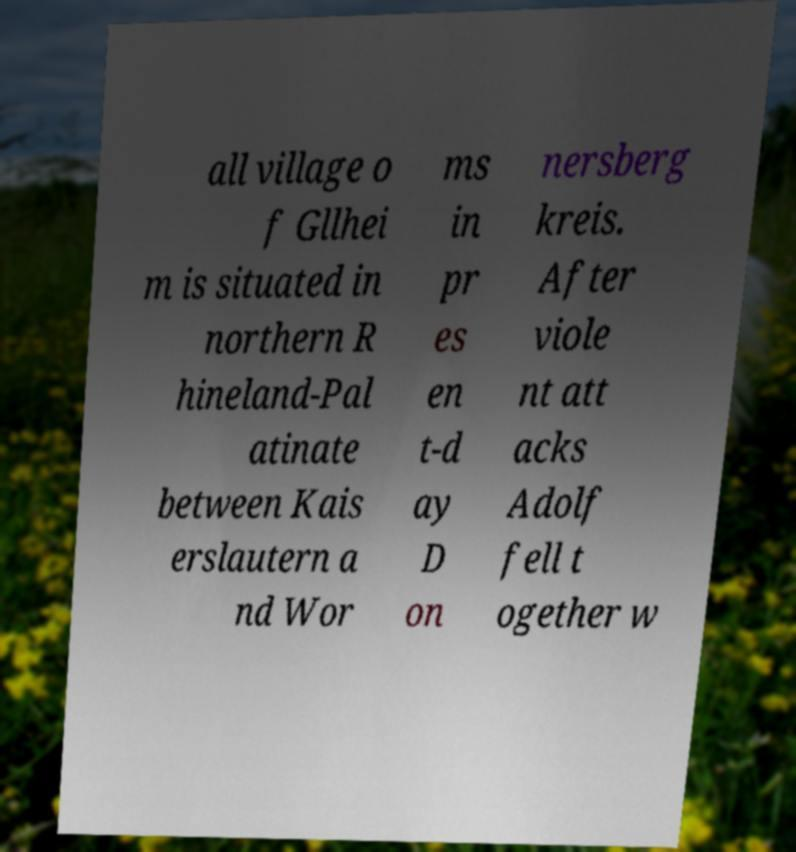Please read and relay the text visible in this image. What does it say? all village o f Gllhei m is situated in northern R hineland-Pal atinate between Kais erslautern a nd Wor ms in pr es en t-d ay D on nersberg kreis. After viole nt att acks Adolf fell t ogether w 